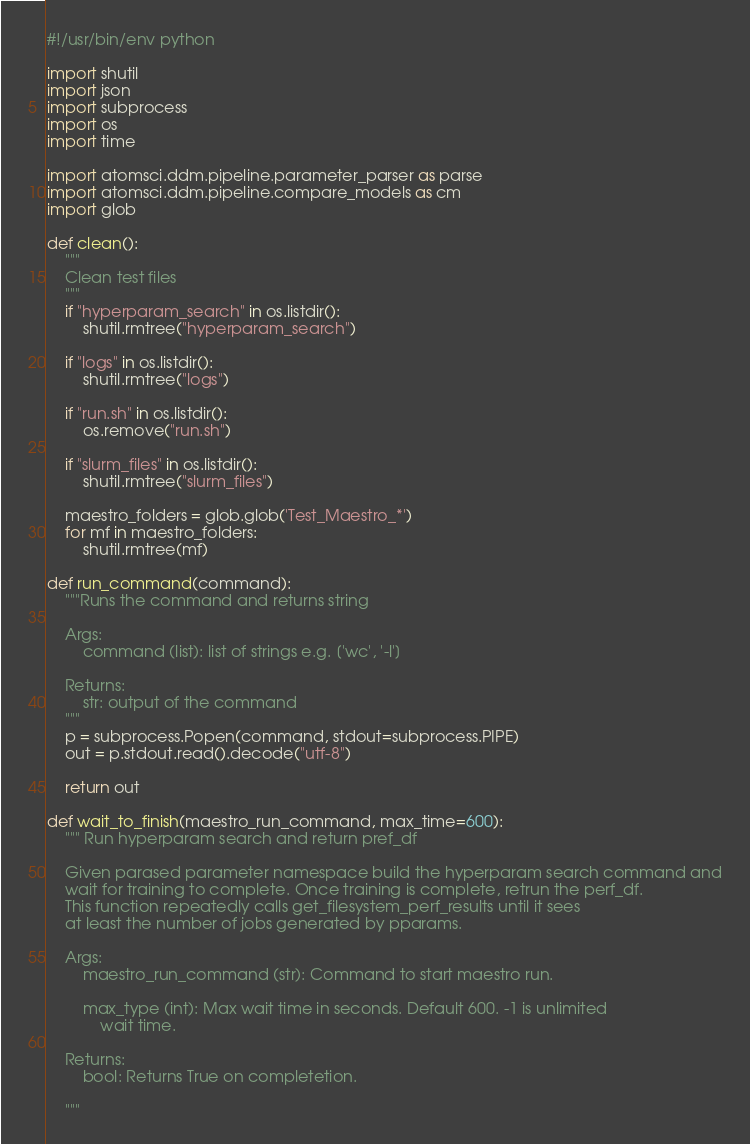Convert code to text. <code><loc_0><loc_0><loc_500><loc_500><_Python_>#!/usr/bin/env python

import shutil
import json
import subprocess
import os
import time

import atomsci.ddm.pipeline.parameter_parser as parse
import atomsci.ddm.pipeline.compare_models as cm
import glob

def clean():
    """
    Clean test files
    """
    if "hyperparam_search" in os.listdir():
        shutil.rmtree("hyperparam_search")

    if "logs" in os.listdir():
        shutil.rmtree("logs")

    if "run.sh" in os.listdir():
        os.remove("run.sh")

    if "slurm_files" in os.listdir():
        shutil.rmtree("slurm_files")

    maestro_folders = glob.glob('Test_Maestro_*')
    for mf in maestro_folders:
        shutil.rmtree(mf)

def run_command(command):
    """Runs the command and returns string

    Args:
        command (list): list of strings e.g. ['wc', '-l']

    Returns:
        str: output of the command
    """
    p = subprocess.Popen(command, stdout=subprocess.PIPE)
    out = p.stdout.read().decode("utf-8")

    return out

def wait_to_finish(maestro_run_command, max_time=600):
    """ Run hyperparam search and return pref_df

    Given parased parameter namespace build the hyperparam search command and
    wait for training to complete. Once training is complete, retrun the perf_df.
    This function repeatedly calls get_filesystem_perf_results until it sees
    at least the number of jobs generated by pparams.

    Args:
        maestro_run_command (str): Command to start maestro run.

        max_type (int): Max wait time in seconds. Default 600. -1 is unlimited
            wait time.

    Returns:
        bool: Returns True on completetion. 

    """</code> 